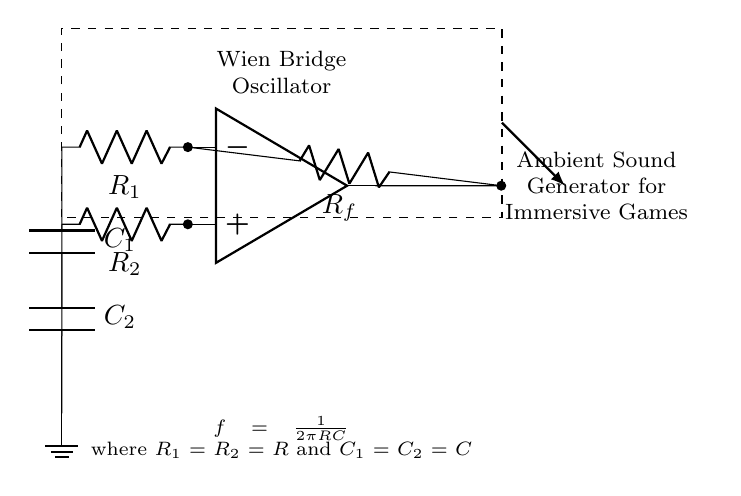What types of components are used in this circuit? The components used in the Wien bridge oscillator include resistors and capacitors. Specifically, there are two resistors labeled R1 and R2, and two capacitors labeled C1 and C2, all connected to an operational amplifier.
Answer: resistors and capacitors What is the purpose of the operational amplifier in this circuit? The operational amplifier in the Wien bridge oscillator is used to amplify the output signal, creating feedback that allows the circuit to oscillate at a certain frequency determined by the resistor and capacitor values.
Answer: amplify What is the relation between frequency and the values of R and C? The frequency of oscillation is determined by the formula f = 1 divided by 2 times pi times R times C, where R1 equals R2 and C1 equals C2. This indicates that increasing R or C will decrease the frequency of the output signal.
Answer: f = 1 / 2πRC How many resistors are present in the circuit? The circuit diagram shows a total of three resistors. Two are labeled R1 and R2, and one is the feedback resistor Rf.
Answer: three What is the function of capacitors C1 and C2 in this oscillator? The capacitors C1 and C2 in the Wien bridge oscillator help control the frequency of oscillation. They work together with the resistors to set the timing of the circuit, influencing the output frequency of the generated oscillation.
Answer: control frequency What happens if R1 and R2 are not equal in this circuit? If R1 and R2 are not equal, the oscillator condition won't be satisfied. This can lead to a failure to achieve oscillation or result in distorted output, as the balance required for stable frequency generation will be disrupted.
Answer: failure to oscillate 